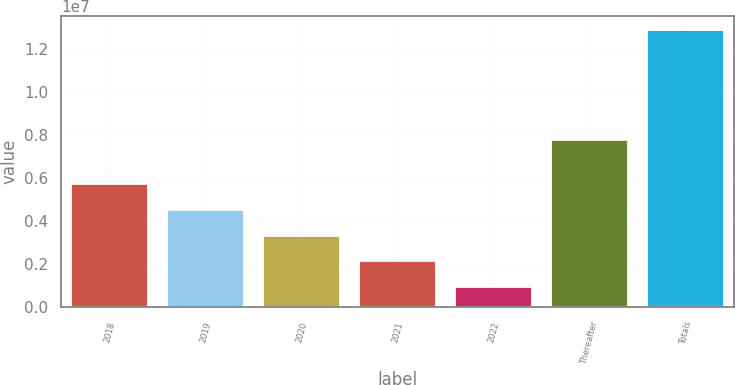Convert chart to OTSL. <chart><loc_0><loc_0><loc_500><loc_500><bar_chart><fcel>2018<fcel>2019<fcel>2020<fcel>2021<fcel>2022<fcel>Thereafter<fcel>Totals<nl><fcel>5.72089e+06<fcel>4.52668e+06<fcel>3.33246e+06<fcel>2.13824e+06<fcel>944028<fcel>7.77114e+06<fcel>1.28862e+07<nl></chart> 